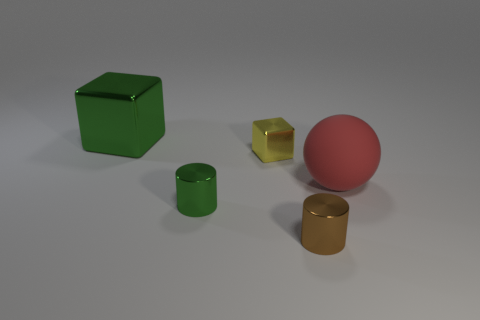Add 5 tiny brown objects. How many objects exist? 10 Subtract 1 spheres. How many spheres are left? 0 Subtract all cubes. How many objects are left? 3 Add 5 green objects. How many green objects are left? 7 Add 1 tiny blue rubber things. How many tiny blue rubber things exist? 1 Subtract 0 cyan blocks. How many objects are left? 5 Subtract all purple balls. Subtract all cyan blocks. How many balls are left? 1 Subtract all big red rubber things. Subtract all yellow metallic cubes. How many objects are left? 3 